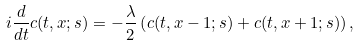<formula> <loc_0><loc_0><loc_500><loc_500>i \frac { d } { d t } c ( t , x ; s ) = - \frac { \lambda } { 2 } \left ( c ( t , x - 1 ; s ) + c ( t , x + 1 ; s ) \right ) ,</formula> 